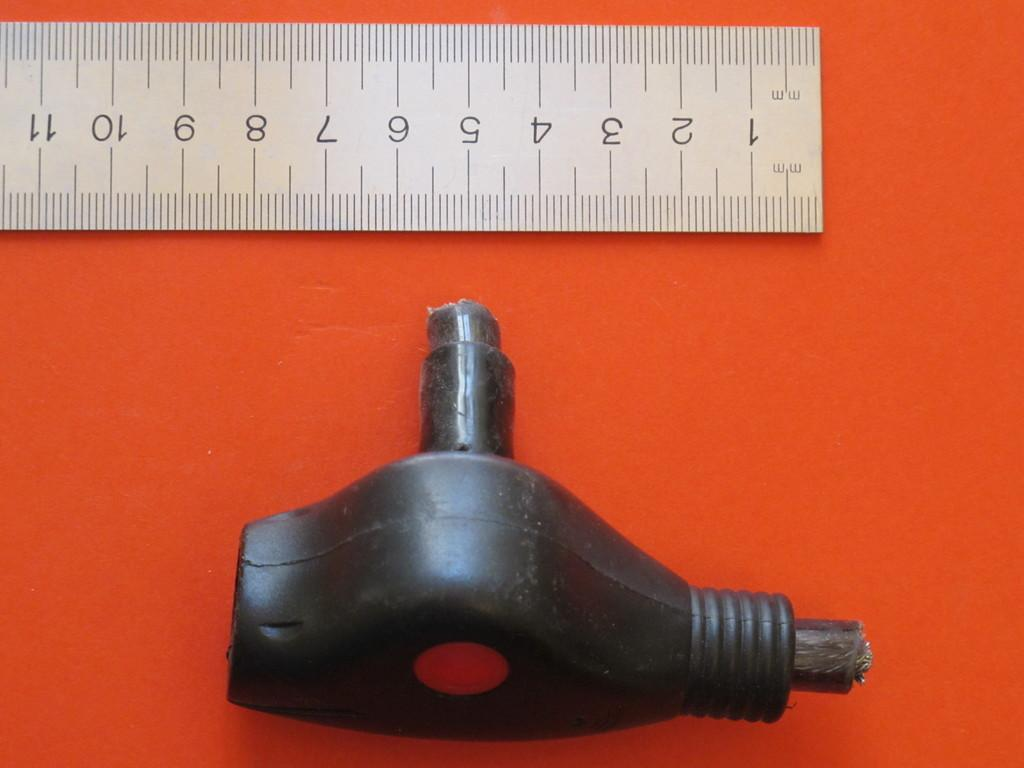<image>
Write a terse but informative summary of the picture. A piece of rubber is on an orange table by a ruler that is marked with numbers 1 through 11. 